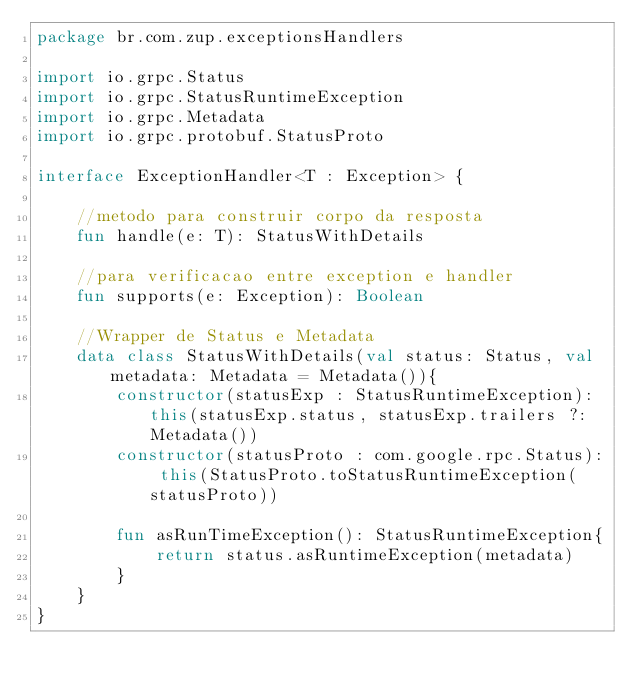Convert code to text. <code><loc_0><loc_0><loc_500><loc_500><_Kotlin_>package br.com.zup.exceptionsHandlers

import io.grpc.Status
import io.grpc.StatusRuntimeException
import io.grpc.Metadata
import io.grpc.protobuf.StatusProto

interface ExceptionHandler<T : Exception> {

    //metodo para construir corpo da resposta
    fun handle(e: T): StatusWithDetails

    //para verificacao entre exception e handler
    fun supports(e: Exception): Boolean

    //Wrapper de Status e Metadata
    data class StatusWithDetails(val status: Status, val metadata: Metadata = Metadata()){
        constructor(statusExp : StatusRuntimeException): this(statusExp.status, statusExp.trailers ?: Metadata())
        constructor(statusProto : com.google.rpc.Status): this(StatusProto.toStatusRuntimeException(statusProto))

        fun asRunTimeException(): StatusRuntimeException{
            return status.asRuntimeException(metadata)
        }
    }
}
</code> 